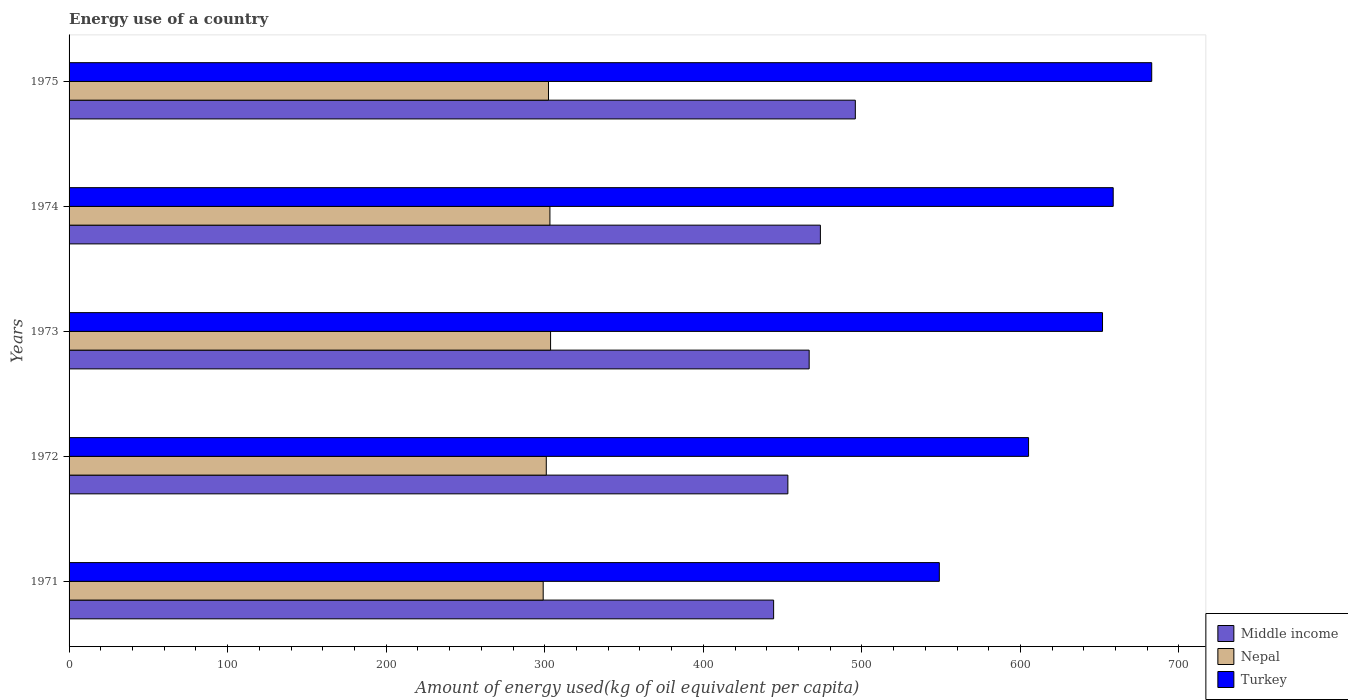How many different coloured bars are there?
Give a very brief answer. 3. Are the number of bars per tick equal to the number of legend labels?
Your answer should be compact. Yes. How many bars are there on the 4th tick from the top?
Keep it short and to the point. 3. How many bars are there on the 1st tick from the bottom?
Offer a very short reply. 3. What is the label of the 2nd group of bars from the top?
Ensure brevity in your answer.  1974. In how many cases, is the number of bars for a given year not equal to the number of legend labels?
Make the answer very short. 0. What is the amount of energy used in in Nepal in 1974?
Offer a very short reply. 303.26. Across all years, what is the maximum amount of energy used in in Nepal?
Provide a succinct answer. 303.68. Across all years, what is the minimum amount of energy used in in Nepal?
Give a very brief answer. 299.02. In which year was the amount of energy used in in Middle income maximum?
Offer a terse response. 1975. What is the total amount of energy used in in Middle income in the graph?
Ensure brevity in your answer.  2334.17. What is the difference between the amount of energy used in in Nepal in 1972 and that in 1975?
Your answer should be very brief. -1.39. What is the difference between the amount of energy used in in Turkey in 1973 and the amount of energy used in in Middle income in 1972?
Ensure brevity in your answer.  198.44. What is the average amount of energy used in in Turkey per year?
Offer a very short reply. 629.42. In the year 1973, what is the difference between the amount of energy used in in Middle income and amount of energy used in in Nepal?
Offer a very short reply. 163.09. What is the ratio of the amount of energy used in in Middle income in 1973 to that in 1975?
Provide a succinct answer. 0.94. Is the amount of energy used in in Turkey in 1971 less than that in 1975?
Provide a short and direct response. Yes. What is the difference between the highest and the second highest amount of energy used in in Turkey?
Your response must be concise. 24.29. What is the difference between the highest and the lowest amount of energy used in in Turkey?
Give a very brief answer. 133.95. In how many years, is the amount of energy used in in Nepal greater than the average amount of energy used in in Nepal taken over all years?
Provide a short and direct response. 3. Is the sum of the amount of energy used in in Middle income in 1974 and 1975 greater than the maximum amount of energy used in in Turkey across all years?
Your answer should be very brief. Yes. What does the 1st bar from the top in 1971 represents?
Ensure brevity in your answer.  Turkey. What does the 3rd bar from the bottom in 1972 represents?
Provide a succinct answer. Turkey. How many bars are there?
Provide a short and direct response. 15. Does the graph contain any zero values?
Give a very brief answer. No. Does the graph contain grids?
Your answer should be compact. No. Where does the legend appear in the graph?
Make the answer very short. Bottom right. How many legend labels are there?
Offer a very short reply. 3. How are the legend labels stacked?
Your answer should be compact. Vertical. What is the title of the graph?
Provide a succinct answer. Energy use of a country. What is the label or title of the X-axis?
Give a very brief answer. Amount of energy used(kg of oil equivalent per capita). What is the label or title of the Y-axis?
Ensure brevity in your answer.  Years. What is the Amount of energy used(kg of oil equivalent per capita) in Middle income in 1971?
Your response must be concise. 444.35. What is the Amount of energy used(kg of oil equivalent per capita) of Nepal in 1971?
Your response must be concise. 299.02. What is the Amount of energy used(kg of oil equivalent per capita) in Turkey in 1971?
Provide a succinct answer. 548.86. What is the Amount of energy used(kg of oil equivalent per capita) in Middle income in 1972?
Ensure brevity in your answer.  453.34. What is the Amount of energy used(kg of oil equivalent per capita) of Nepal in 1972?
Give a very brief answer. 300.97. What is the Amount of energy used(kg of oil equivalent per capita) in Turkey in 1972?
Ensure brevity in your answer.  605.14. What is the Amount of energy used(kg of oil equivalent per capita) in Middle income in 1973?
Offer a terse response. 466.77. What is the Amount of energy used(kg of oil equivalent per capita) of Nepal in 1973?
Give a very brief answer. 303.68. What is the Amount of energy used(kg of oil equivalent per capita) in Turkey in 1973?
Your answer should be compact. 651.78. What is the Amount of energy used(kg of oil equivalent per capita) in Middle income in 1974?
Offer a very short reply. 473.84. What is the Amount of energy used(kg of oil equivalent per capita) in Nepal in 1974?
Provide a short and direct response. 303.26. What is the Amount of energy used(kg of oil equivalent per capita) in Turkey in 1974?
Keep it short and to the point. 658.52. What is the Amount of energy used(kg of oil equivalent per capita) of Middle income in 1975?
Your answer should be compact. 495.88. What is the Amount of energy used(kg of oil equivalent per capita) of Nepal in 1975?
Offer a very short reply. 302.36. What is the Amount of energy used(kg of oil equivalent per capita) in Turkey in 1975?
Your answer should be very brief. 682.81. Across all years, what is the maximum Amount of energy used(kg of oil equivalent per capita) of Middle income?
Keep it short and to the point. 495.88. Across all years, what is the maximum Amount of energy used(kg of oil equivalent per capita) of Nepal?
Ensure brevity in your answer.  303.68. Across all years, what is the maximum Amount of energy used(kg of oil equivalent per capita) in Turkey?
Make the answer very short. 682.81. Across all years, what is the minimum Amount of energy used(kg of oil equivalent per capita) in Middle income?
Your answer should be very brief. 444.35. Across all years, what is the minimum Amount of energy used(kg of oil equivalent per capita) in Nepal?
Ensure brevity in your answer.  299.02. Across all years, what is the minimum Amount of energy used(kg of oil equivalent per capita) in Turkey?
Offer a very short reply. 548.86. What is the total Amount of energy used(kg of oil equivalent per capita) of Middle income in the graph?
Make the answer very short. 2334.17. What is the total Amount of energy used(kg of oil equivalent per capita) in Nepal in the graph?
Provide a short and direct response. 1509.29. What is the total Amount of energy used(kg of oil equivalent per capita) in Turkey in the graph?
Your response must be concise. 3147.1. What is the difference between the Amount of energy used(kg of oil equivalent per capita) of Middle income in 1971 and that in 1972?
Ensure brevity in your answer.  -8.99. What is the difference between the Amount of energy used(kg of oil equivalent per capita) of Nepal in 1971 and that in 1972?
Offer a very short reply. -1.95. What is the difference between the Amount of energy used(kg of oil equivalent per capita) in Turkey in 1971 and that in 1972?
Make the answer very short. -56.28. What is the difference between the Amount of energy used(kg of oil equivalent per capita) of Middle income in 1971 and that in 1973?
Offer a very short reply. -22.42. What is the difference between the Amount of energy used(kg of oil equivalent per capita) of Nepal in 1971 and that in 1973?
Provide a succinct answer. -4.66. What is the difference between the Amount of energy used(kg of oil equivalent per capita) in Turkey in 1971 and that in 1973?
Offer a very short reply. -102.92. What is the difference between the Amount of energy used(kg of oil equivalent per capita) of Middle income in 1971 and that in 1974?
Provide a short and direct response. -29.49. What is the difference between the Amount of energy used(kg of oil equivalent per capita) of Nepal in 1971 and that in 1974?
Your answer should be compact. -4.24. What is the difference between the Amount of energy used(kg of oil equivalent per capita) in Turkey in 1971 and that in 1974?
Keep it short and to the point. -109.67. What is the difference between the Amount of energy used(kg of oil equivalent per capita) of Middle income in 1971 and that in 1975?
Keep it short and to the point. -51.53. What is the difference between the Amount of energy used(kg of oil equivalent per capita) in Nepal in 1971 and that in 1975?
Ensure brevity in your answer.  -3.34. What is the difference between the Amount of energy used(kg of oil equivalent per capita) in Turkey in 1971 and that in 1975?
Ensure brevity in your answer.  -133.95. What is the difference between the Amount of energy used(kg of oil equivalent per capita) of Middle income in 1972 and that in 1973?
Your response must be concise. -13.43. What is the difference between the Amount of energy used(kg of oil equivalent per capita) of Nepal in 1972 and that in 1973?
Provide a succinct answer. -2.7. What is the difference between the Amount of energy used(kg of oil equivalent per capita) of Turkey in 1972 and that in 1973?
Give a very brief answer. -46.64. What is the difference between the Amount of energy used(kg of oil equivalent per capita) of Middle income in 1972 and that in 1974?
Keep it short and to the point. -20.51. What is the difference between the Amount of energy used(kg of oil equivalent per capita) of Nepal in 1972 and that in 1974?
Make the answer very short. -2.29. What is the difference between the Amount of energy used(kg of oil equivalent per capita) of Turkey in 1972 and that in 1974?
Your response must be concise. -53.39. What is the difference between the Amount of energy used(kg of oil equivalent per capita) in Middle income in 1972 and that in 1975?
Make the answer very short. -42.54. What is the difference between the Amount of energy used(kg of oil equivalent per capita) of Nepal in 1972 and that in 1975?
Give a very brief answer. -1.39. What is the difference between the Amount of energy used(kg of oil equivalent per capita) of Turkey in 1972 and that in 1975?
Your answer should be very brief. -77.67. What is the difference between the Amount of energy used(kg of oil equivalent per capita) of Middle income in 1973 and that in 1974?
Keep it short and to the point. -7.08. What is the difference between the Amount of energy used(kg of oil equivalent per capita) of Nepal in 1973 and that in 1974?
Your answer should be very brief. 0.41. What is the difference between the Amount of energy used(kg of oil equivalent per capita) of Turkey in 1973 and that in 1974?
Your answer should be compact. -6.75. What is the difference between the Amount of energy used(kg of oil equivalent per capita) of Middle income in 1973 and that in 1975?
Your response must be concise. -29.11. What is the difference between the Amount of energy used(kg of oil equivalent per capita) in Nepal in 1973 and that in 1975?
Offer a very short reply. 1.32. What is the difference between the Amount of energy used(kg of oil equivalent per capita) of Turkey in 1973 and that in 1975?
Provide a succinct answer. -31.03. What is the difference between the Amount of energy used(kg of oil equivalent per capita) of Middle income in 1974 and that in 1975?
Your response must be concise. -22.04. What is the difference between the Amount of energy used(kg of oil equivalent per capita) of Nepal in 1974 and that in 1975?
Offer a terse response. 0.9. What is the difference between the Amount of energy used(kg of oil equivalent per capita) in Turkey in 1974 and that in 1975?
Provide a succinct answer. -24.29. What is the difference between the Amount of energy used(kg of oil equivalent per capita) of Middle income in 1971 and the Amount of energy used(kg of oil equivalent per capita) of Nepal in 1972?
Provide a succinct answer. 143.38. What is the difference between the Amount of energy used(kg of oil equivalent per capita) of Middle income in 1971 and the Amount of energy used(kg of oil equivalent per capita) of Turkey in 1972?
Provide a succinct answer. -160.79. What is the difference between the Amount of energy used(kg of oil equivalent per capita) of Nepal in 1971 and the Amount of energy used(kg of oil equivalent per capita) of Turkey in 1972?
Your response must be concise. -306.12. What is the difference between the Amount of energy used(kg of oil equivalent per capita) of Middle income in 1971 and the Amount of energy used(kg of oil equivalent per capita) of Nepal in 1973?
Ensure brevity in your answer.  140.67. What is the difference between the Amount of energy used(kg of oil equivalent per capita) of Middle income in 1971 and the Amount of energy used(kg of oil equivalent per capita) of Turkey in 1973?
Provide a short and direct response. -207.43. What is the difference between the Amount of energy used(kg of oil equivalent per capita) of Nepal in 1971 and the Amount of energy used(kg of oil equivalent per capita) of Turkey in 1973?
Make the answer very short. -352.76. What is the difference between the Amount of energy used(kg of oil equivalent per capita) of Middle income in 1971 and the Amount of energy used(kg of oil equivalent per capita) of Nepal in 1974?
Your response must be concise. 141.09. What is the difference between the Amount of energy used(kg of oil equivalent per capita) of Middle income in 1971 and the Amount of energy used(kg of oil equivalent per capita) of Turkey in 1974?
Provide a short and direct response. -214.17. What is the difference between the Amount of energy used(kg of oil equivalent per capita) of Nepal in 1971 and the Amount of energy used(kg of oil equivalent per capita) of Turkey in 1974?
Your response must be concise. -359.5. What is the difference between the Amount of energy used(kg of oil equivalent per capita) in Middle income in 1971 and the Amount of energy used(kg of oil equivalent per capita) in Nepal in 1975?
Your answer should be very brief. 141.99. What is the difference between the Amount of energy used(kg of oil equivalent per capita) in Middle income in 1971 and the Amount of energy used(kg of oil equivalent per capita) in Turkey in 1975?
Offer a very short reply. -238.46. What is the difference between the Amount of energy used(kg of oil equivalent per capita) of Nepal in 1971 and the Amount of energy used(kg of oil equivalent per capita) of Turkey in 1975?
Your answer should be compact. -383.79. What is the difference between the Amount of energy used(kg of oil equivalent per capita) of Middle income in 1972 and the Amount of energy used(kg of oil equivalent per capita) of Nepal in 1973?
Offer a terse response. 149.66. What is the difference between the Amount of energy used(kg of oil equivalent per capita) of Middle income in 1972 and the Amount of energy used(kg of oil equivalent per capita) of Turkey in 1973?
Ensure brevity in your answer.  -198.44. What is the difference between the Amount of energy used(kg of oil equivalent per capita) of Nepal in 1972 and the Amount of energy used(kg of oil equivalent per capita) of Turkey in 1973?
Give a very brief answer. -350.8. What is the difference between the Amount of energy used(kg of oil equivalent per capita) of Middle income in 1972 and the Amount of energy used(kg of oil equivalent per capita) of Nepal in 1974?
Offer a very short reply. 150.07. What is the difference between the Amount of energy used(kg of oil equivalent per capita) of Middle income in 1972 and the Amount of energy used(kg of oil equivalent per capita) of Turkey in 1974?
Give a very brief answer. -205.19. What is the difference between the Amount of energy used(kg of oil equivalent per capita) of Nepal in 1972 and the Amount of energy used(kg of oil equivalent per capita) of Turkey in 1974?
Offer a very short reply. -357.55. What is the difference between the Amount of energy used(kg of oil equivalent per capita) of Middle income in 1972 and the Amount of energy used(kg of oil equivalent per capita) of Nepal in 1975?
Keep it short and to the point. 150.98. What is the difference between the Amount of energy used(kg of oil equivalent per capita) of Middle income in 1972 and the Amount of energy used(kg of oil equivalent per capita) of Turkey in 1975?
Your response must be concise. -229.47. What is the difference between the Amount of energy used(kg of oil equivalent per capita) in Nepal in 1972 and the Amount of energy used(kg of oil equivalent per capita) in Turkey in 1975?
Make the answer very short. -381.84. What is the difference between the Amount of energy used(kg of oil equivalent per capita) of Middle income in 1973 and the Amount of energy used(kg of oil equivalent per capita) of Nepal in 1974?
Make the answer very short. 163.5. What is the difference between the Amount of energy used(kg of oil equivalent per capita) in Middle income in 1973 and the Amount of energy used(kg of oil equivalent per capita) in Turkey in 1974?
Give a very brief answer. -191.75. What is the difference between the Amount of energy used(kg of oil equivalent per capita) of Nepal in 1973 and the Amount of energy used(kg of oil equivalent per capita) of Turkey in 1974?
Your response must be concise. -354.84. What is the difference between the Amount of energy used(kg of oil equivalent per capita) in Middle income in 1973 and the Amount of energy used(kg of oil equivalent per capita) in Nepal in 1975?
Provide a short and direct response. 164.41. What is the difference between the Amount of energy used(kg of oil equivalent per capita) of Middle income in 1973 and the Amount of energy used(kg of oil equivalent per capita) of Turkey in 1975?
Keep it short and to the point. -216.04. What is the difference between the Amount of energy used(kg of oil equivalent per capita) of Nepal in 1973 and the Amount of energy used(kg of oil equivalent per capita) of Turkey in 1975?
Provide a succinct answer. -379.13. What is the difference between the Amount of energy used(kg of oil equivalent per capita) in Middle income in 1974 and the Amount of energy used(kg of oil equivalent per capita) in Nepal in 1975?
Make the answer very short. 171.48. What is the difference between the Amount of energy used(kg of oil equivalent per capita) of Middle income in 1974 and the Amount of energy used(kg of oil equivalent per capita) of Turkey in 1975?
Give a very brief answer. -208.97. What is the difference between the Amount of energy used(kg of oil equivalent per capita) of Nepal in 1974 and the Amount of energy used(kg of oil equivalent per capita) of Turkey in 1975?
Ensure brevity in your answer.  -379.55. What is the average Amount of energy used(kg of oil equivalent per capita) in Middle income per year?
Offer a very short reply. 466.83. What is the average Amount of energy used(kg of oil equivalent per capita) in Nepal per year?
Keep it short and to the point. 301.86. What is the average Amount of energy used(kg of oil equivalent per capita) of Turkey per year?
Give a very brief answer. 629.42. In the year 1971, what is the difference between the Amount of energy used(kg of oil equivalent per capita) in Middle income and Amount of energy used(kg of oil equivalent per capita) in Nepal?
Your answer should be very brief. 145.33. In the year 1971, what is the difference between the Amount of energy used(kg of oil equivalent per capita) in Middle income and Amount of energy used(kg of oil equivalent per capita) in Turkey?
Offer a very short reply. -104.51. In the year 1971, what is the difference between the Amount of energy used(kg of oil equivalent per capita) in Nepal and Amount of energy used(kg of oil equivalent per capita) in Turkey?
Provide a succinct answer. -249.84. In the year 1972, what is the difference between the Amount of energy used(kg of oil equivalent per capita) of Middle income and Amount of energy used(kg of oil equivalent per capita) of Nepal?
Keep it short and to the point. 152.36. In the year 1972, what is the difference between the Amount of energy used(kg of oil equivalent per capita) in Middle income and Amount of energy used(kg of oil equivalent per capita) in Turkey?
Provide a short and direct response. -151.8. In the year 1972, what is the difference between the Amount of energy used(kg of oil equivalent per capita) in Nepal and Amount of energy used(kg of oil equivalent per capita) in Turkey?
Make the answer very short. -304.16. In the year 1973, what is the difference between the Amount of energy used(kg of oil equivalent per capita) of Middle income and Amount of energy used(kg of oil equivalent per capita) of Nepal?
Make the answer very short. 163.09. In the year 1973, what is the difference between the Amount of energy used(kg of oil equivalent per capita) in Middle income and Amount of energy used(kg of oil equivalent per capita) in Turkey?
Provide a short and direct response. -185.01. In the year 1973, what is the difference between the Amount of energy used(kg of oil equivalent per capita) in Nepal and Amount of energy used(kg of oil equivalent per capita) in Turkey?
Ensure brevity in your answer.  -348.1. In the year 1974, what is the difference between the Amount of energy used(kg of oil equivalent per capita) in Middle income and Amount of energy used(kg of oil equivalent per capita) in Nepal?
Your answer should be very brief. 170.58. In the year 1974, what is the difference between the Amount of energy used(kg of oil equivalent per capita) in Middle income and Amount of energy used(kg of oil equivalent per capita) in Turkey?
Offer a terse response. -184.68. In the year 1974, what is the difference between the Amount of energy used(kg of oil equivalent per capita) in Nepal and Amount of energy used(kg of oil equivalent per capita) in Turkey?
Ensure brevity in your answer.  -355.26. In the year 1975, what is the difference between the Amount of energy used(kg of oil equivalent per capita) in Middle income and Amount of energy used(kg of oil equivalent per capita) in Nepal?
Offer a terse response. 193.52. In the year 1975, what is the difference between the Amount of energy used(kg of oil equivalent per capita) of Middle income and Amount of energy used(kg of oil equivalent per capita) of Turkey?
Give a very brief answer. -186.93. In the year 1975, what is the difference between the Amount of energy used(kg of oil equivalent per capita) in Nepal and Amount of energy used(kg of oil equivalent per capita) in Turkey?
Your answer should be compact. -380.45. What is the ratio of the Amount of energy used(kg of oil equivalent per capita) in Middle income in 1971 to that in 1972?
Provide a succinct answer. 0.98. What is the ratio of the Amount of energy used(kg of oil equivalent per capita) in Nepal in 1971 to that in 1972?
Provide a succinct answer. 0.99. What is the ratio of the Amount of energy used(kg of oil equivalent per capita) in Turkey in 1971 to that in 1972?
Provide a short and direct response. 0.91. What is the ratio of the Amount of energy used(kg of oil equivalent per capita) in Nepal in 1971 to that in 1973?
Your answer should be compact. 0.98. What is the ratio of the Amount of energy used(kg of oil equivalent per capita) in Turkey in 1971 to that in 1973?
Ensure brevity in your answer.  0.84. What is the ratio of the Amount of energy used(kg of oil equivalent per capita) of Middle income in 1971 to that in 1974?
Ensure brevity in your answer.  0.94. What is the ratio of the Amount of energy used(kg of oil equivalent per capita) in Nepal in 1971 to that in 1974?
Your response must be concise. 0.99. What is the ratio of the Amount of energy used(kg of oil equivalent per capita) of Turkey in 1971 to that in 1974?
Ensure brevity in your answer.  0.83. What is the ratio of the Amount of energy used(kg of oil equivalent per capita) in Middle income in 1971 to that in 1975?
Make the answer very short. 0.9. What is the ratio of the Amount of energy used(kg of oil equivalent per capita) of Nepal in 1971 to that in 1975?
Offer a terse response. 0.99. What is the ratio of the Amount of energy used(kg of oil equivalent per capita) in Turkey in 1971 to that in 1975?
Provide a succinct answer. 0.8. What is the ratio of the Amount of energy used(kg of oil equivalent per capita) in Middle income in 1972 to that in 1973?
Give a very brief answer. 0.97. What is the ratio of the Amount of energy used(kg of oil equivalent per capita) of Nepal in 1972 to that in 1973?
Offer a very short reply. 0.99. What is the ratio of the Amount of energy used(kg of oil equivalent per capita) in Turkey in 1972 to that in 1973?
Give a very brief answer. 0.93. What is the ratio of the Amount of energy used(kg of oil equivalent per capita) of Middle income in 1972 to that in 1974?
Ensure brevity in your answer.  0.96. What is the ratio of the Amount of energy used(kg of oil equivalent per capita) in Turkey in 1972 to that in 1974?
Keep it short and to the point. 0.92. What is the ratio of the Amount of energy used(kg of oil equivalent per capita) of Middle income in 1972 to that in 1975?
Make the answer very short. 0.91. What is the ratio of the Amount of energy used(kg of oil equivalent per capita) in Turkey in 1972 to that in 1975?
Your response must be concise. 0.89. What is the ratio of the Amount of energy used(kg of oil equivalent per capita) in Middle income in 1973 to that in 1974?
Offer a very short reply. 0.99. What is the ratio of the Amount of energy used(kg of oil equivalent per capita) in Nepal in 1973 to that in 1974?
Ensure brevity in your answer.  1. What is the ratio of the Amount of energy used(kg of oil equivalent per capita) of Turkey in 1973 to that in 1974?
Your answer should be compact. 0.99. What is the ratio of the Amount of energy used(kg of oil equivalent per capita) of Middle income in 1973 to that in 1975?
Ensure brevity in your answer.  0.94. What is the ratio of the Amount of energy used(kg of oil equivalent per capita) in Nepal in 1973 to that in 1975?
Give a very brief answer. 1. What is the ratio of the Amount of energy used(kg of oil equivalent per capita) in Turkey in 1973 to that in 1975?
Your answer should be compact. 0.95. What is the ratio of the Amount of energy used(kg of oil equivalent per capita) in Middle income in 1974 to that in 1975?
Your answer should be compact. 0.96. What is the ratio of the Amount of energy used(kg of oil equivalent per capita) of Turkey in 1974 to that in 1975?
Your response must be concise. 0.96. What is the difference between the highest and the second highest Amount of energy used(kg of oil equivalent per capita) of Middle income?
Keep it short and to the point. 22.04. What is the difference between the highest and the second highest Amount of energy used(kg of oil equivalent per capita) in Nepal?
Offer a terse response. 0.41. What is the difference between the highest and the second highest Amount of energy used(kg of oil equivalent per capita) in Turkey?
Make the answer very short. 24.29. What is the difference between the highest and the lowest Amount of energy used(kg of oil equivalent per capita) in Middle income?
Your response must be concise. 51.53. What is the difference between the highest and the lowest Amount of energy used(kg of oil equivalent per capita) of Nepal?
Keep it short and to the point. 4.66. What is the difference between the highest and the lowest Amount of energy used(kg of oil equivalent per capita) of Turkey?
Ensure brevity in your answer.  133.95. 